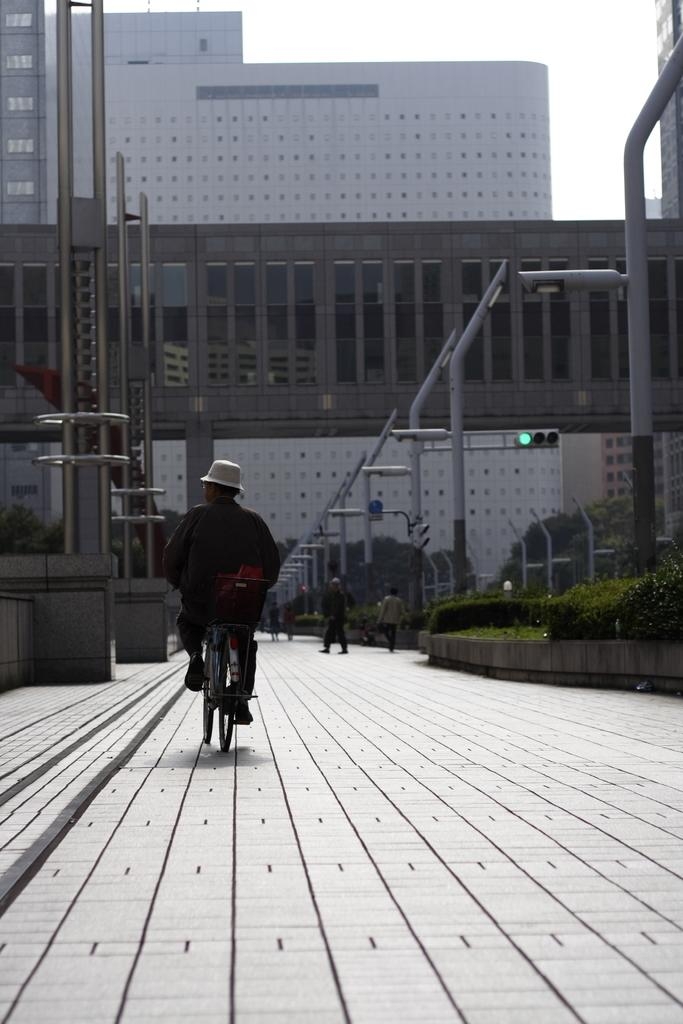What is the man in the image doing? The man is riding a bicycle in the image. What can be seen in the background of the image? There are plants, a road, and buildings visible in the image. What type of decision is the man making while riding the bicycle in the image? There is no indication in the image that the man is making any decisions while riding the bicycle. 